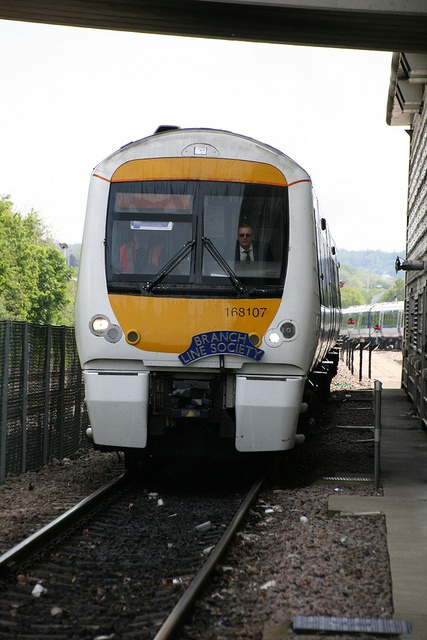Describe the objects in this image and their specific colors. I can see train in black, gray, darkgray, and lightgray tones, train in black, lightgray, gray, and darkgray tones, people in black, gray, brown, and blue tones, people in black, gray, and maroon tones, and tie in black and gray tones in this image. 